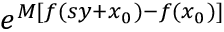Convert formula to latex. <formula><loc_0><loc_0><loc_500><loc_500>e ^ { M [ f ( s y + x _ { 0 } ) - f ( x _ { 0 } ) ] }</formula> 